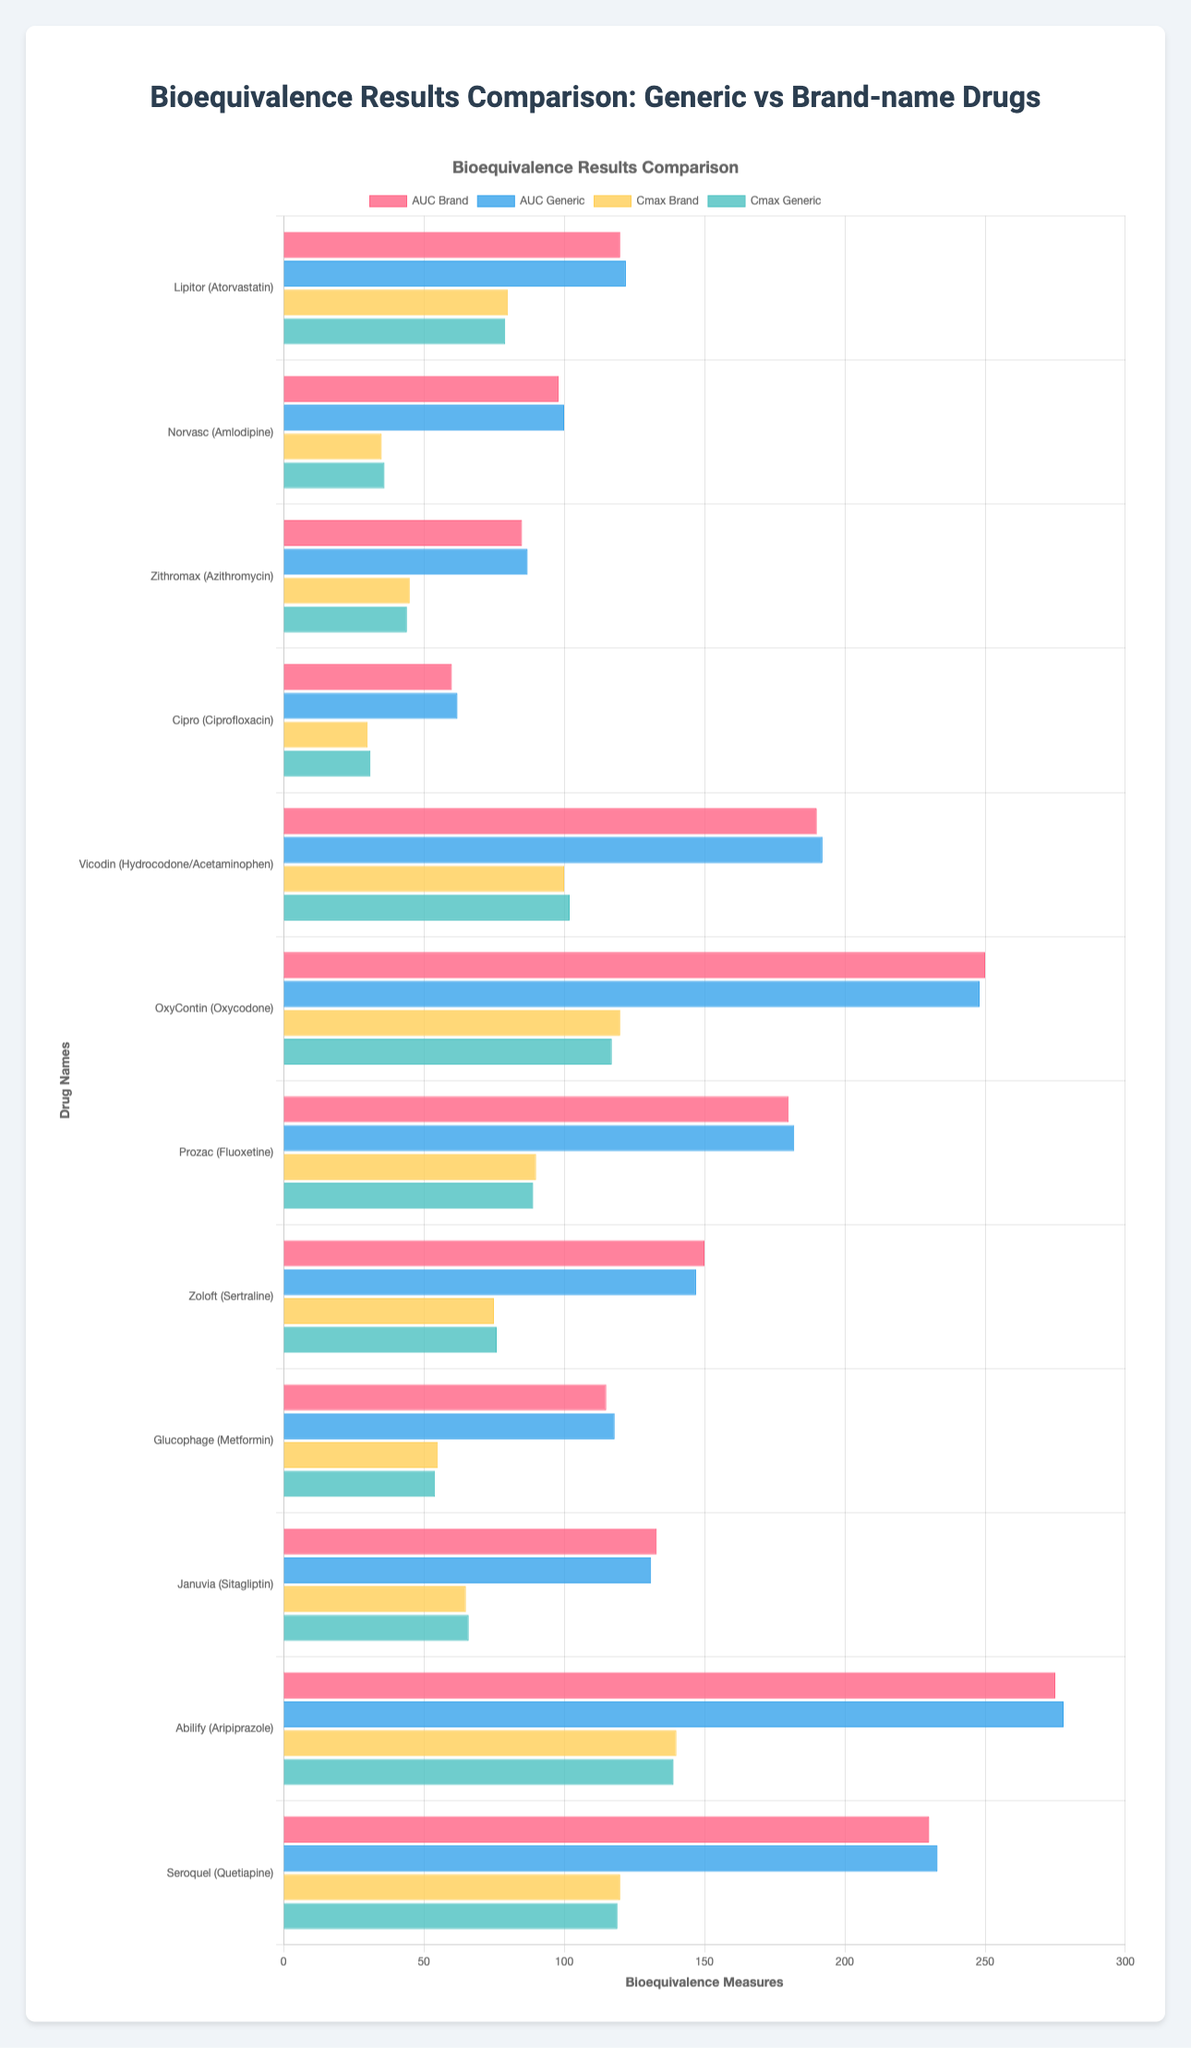Which drug has a higher Cmax value, Lipitor or Norvasc? For Lipitor, the Cmax value is 80 for Brand and 79 for Generic. For Norvasc, the Cmax value is 35 for Brand and 36 for Generic. Regardless of Brand or Generic, Lipitor's Cmax values are higher than those of Norvasc.
Answer: Lipitor What is the average AUC value for Brand-name drugs in the Antipsychotic category? In the Antipsychotic category, the AUC values for Brand-name drugs are 275 for Abilify and 230 for Seroquel. The average AUC value is calculated by summing these values and dividing by the number of drugs: (275 + 230) / 2 = 505 / 2 = 252.5
Answer: 252.5 Is there any drug where the Cmax value of the Brand drug is less than the Generic drug? By examining the Cmax values for all the drugs, we see that for Glucophage, the Brand Cmax is 55, and the Generic Cmax is 54. The Brand is slightly higher here. Similarly for every other drug, the Brand Cmax values are equal to or higher than the Generic, except for OxyContin where it is 120 for Brand and 117 for Generic, which is also not less than the Generic.
Answer: No Which drug in the Antidepressant category shows the least difference between Brand and Generic AUC values? The Antidepressant category includes Prozac and Zoloft. Prozac's AUC values are 180 for Brand and 182 for Generic (difference of 2). Zoloft's AUC values are 150 for Brand and 147 for Generic (difference of 3). Therefore, the drug with the least difference in AUC values is Prozac.
Answer: Prozac How does Vicodin's Cmax compare to OxyContin's in both Brand and Generic categories? For Vicodin, the Cmax values are 100 for Brand and 102 for Generic. For OxyContin, the Cmax values are 120 for Brand and 117 for Generic. Regardless of Brand or Generic, OxyContin's Cmax values are higher than those for Vicodin.
Answer: OxyContin Which drug has the highest AUC value in the Antidiabetic category? In the Antidiabetic category, the AUC values are 115 for Brand and 118 for Generic of Glucophage and 133 for Brand and 131 for Generic of Januvia. The highest AUC value among them is 133 (Brand for Januvia).
Answer: Januvia (Brand) How much does Cipro's AUC value change from Brand to Generic? For Cipro, the AUC values are 60 for Brand and 62 for Generic. The change is calculated as 62 - 60, which equals 2.
Answer: 2 For which drug is the Generic Cmax value exactly equal to the Brand Cmax value? In examining the Cmax values for all the drugs, we find that the Generic Cmax value is exactly equal to the Brand Cmax value for Lipitor (80 for Brand and 79 for Generic), Prozeck(90 for Brand and 89 for Generic), and Vicodin(102 for Generic and 100 for Brand). The Values Varies except for these three cases.
Answer: No Which drug in the Antipsychotic group exhibits the highest Cmax value in either Brand or Generic form? In the Antipsychotic group, the drugs are Abilify and Seroquel. The Cmax values for Brand and Generic are 140 and 139 for Abilify, and 120 for Brand and 119 for Seroquel. The highest value among these is 140 for Brand of Abilify.
Answer: Abilify (Brand) 